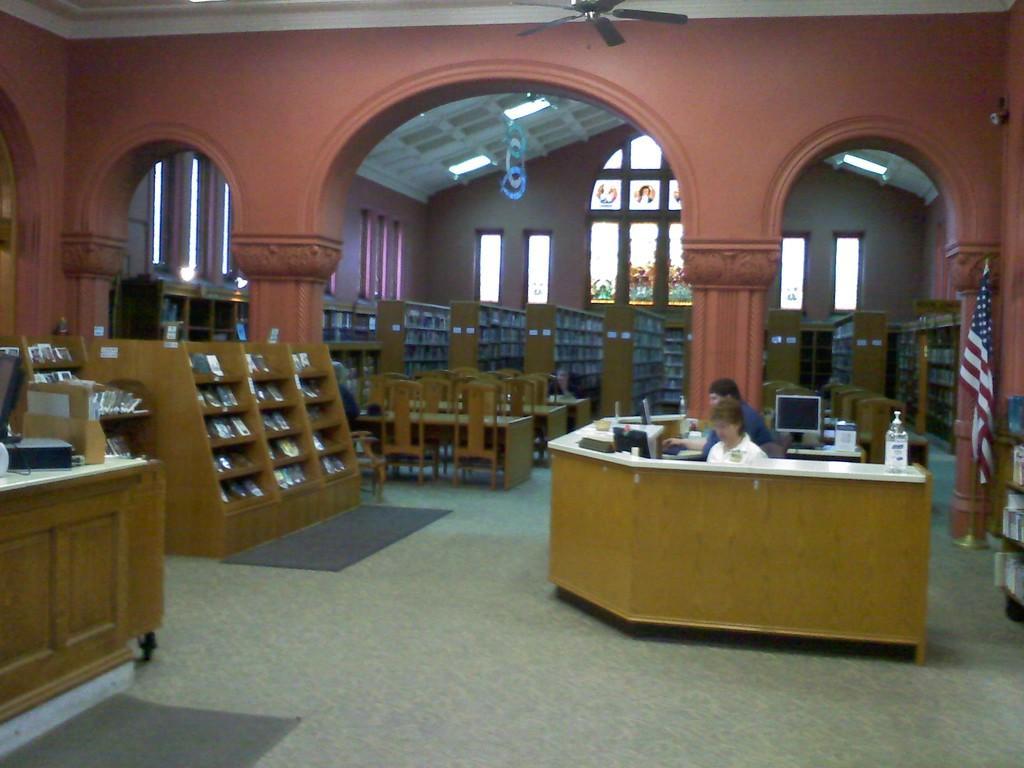In one or two sentences, can you explain what this image depicts? In this image we can see a library room. There are two person sitting on a chair behind the u-shaped desk. On the desk there is a water bottle, computer screen and some books. On the right side there is a flag. On the top there is a fan. On the background we can see a three table and chairs. Here it's a window and a light. 